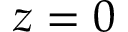Convert formula to latex. <formula><loc_0><loc_0><loc_500><loc_500>z = 0</formula> 